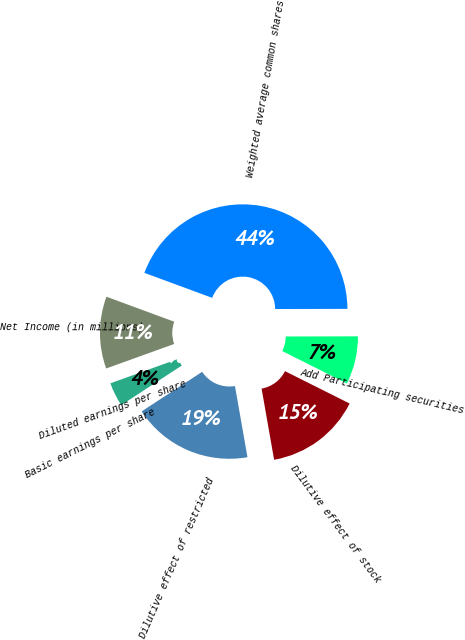Convert chart. <chart><loc_0><loc_0><loc_500><loc_500><pie_chart><fcel>Net Income (in millions)<fcel>Weighted average common shares<fcel>Add Participating securities<fcel>Dilutive effect of stock<fcel>Dilutive effect of restricted<fcel>Basic earnings per share<fcel>Diluted earnings per share<nl><fcel>11.13%<fcel>44.34%<fcel>7.42%<fcel>14.84%<fcel>18.55%<fcel>3.71%<fcel>0.0%<nl></chart> 